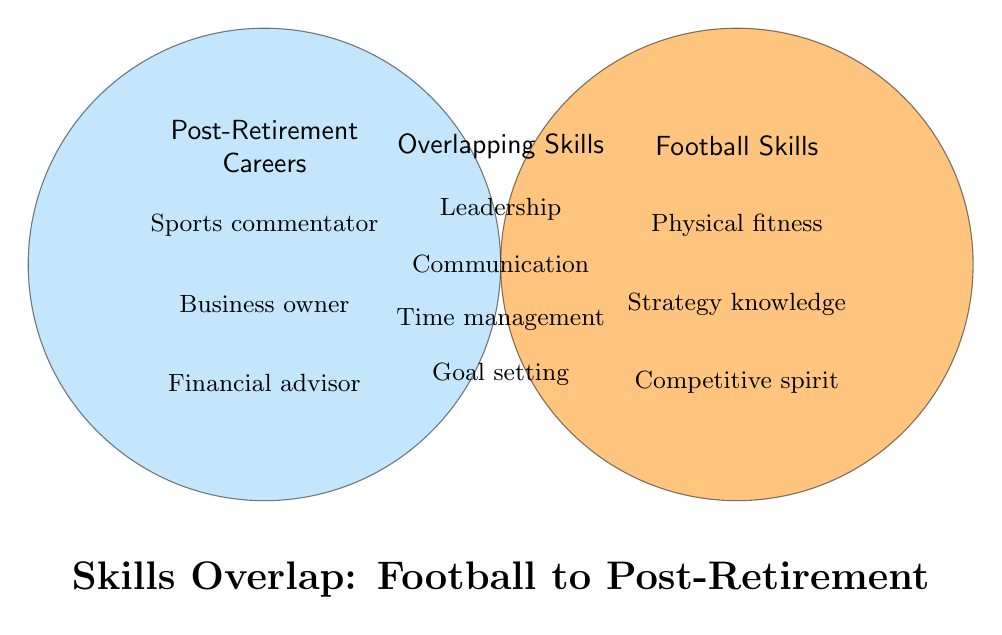What are the categories of skills shown? The diagram has three main categories of skills labeled as Football Skills, Overlapping Skills, and Post-Retirement Careers.
Answer: Football Skills, Overlapping Skills, Post-Retirement Careers Name a skill exclusive to Football Skills. Exclusive skills are those found only within the Football Skills circle and outside the overlapping area. One of these skills is Physical fitness.
Answer: Physical fitness Which category contains the skill 'Leadership'? The skill 'Leadership' is located in the overlapping area between Football Skills and Post-Retirement Careers categories.
Answer: Overlapping Skills Identify a skill that is both an overlapping skill and useful in post-retirement careers. Skills that appear in the Overlapping Skills section are applicable in both categories. One such skill is Communication.
Answer: Communication How many overlapping skills are listed? In the Overlapping Skills section, there are four skills listed.
Answer: Four Which category includes the skill 'Sports commentator'? The skill 'Sports commentator' is found in the Post-Retirement Careers circle.
Answer: Post-Retirement Careers Are there more skills listed in Football Skills or Post-Retirement Careers? By counting the skills in each category, we see that Football Skills has three listed skills, while Post-Retirement Careers has five listed skills. Therefore, Post-Retirement Careers has more skills.
Answer: Post-Retirement Careers Which skill is shared by Career and Football but not listed under "Physical fitness"? To find a shared skill not listed under "Physical fitness", look in the overlapping section. Both Leadership and Communication fit this description.
Answer: Leadership How does the skill 'Time management' relate to the categories? The skill 'Time management' is located in the Overlapping Skills section, meaning it is relevant to both Football Skills and Post-Retirement Careers.
Answer: Overlapping Skills 